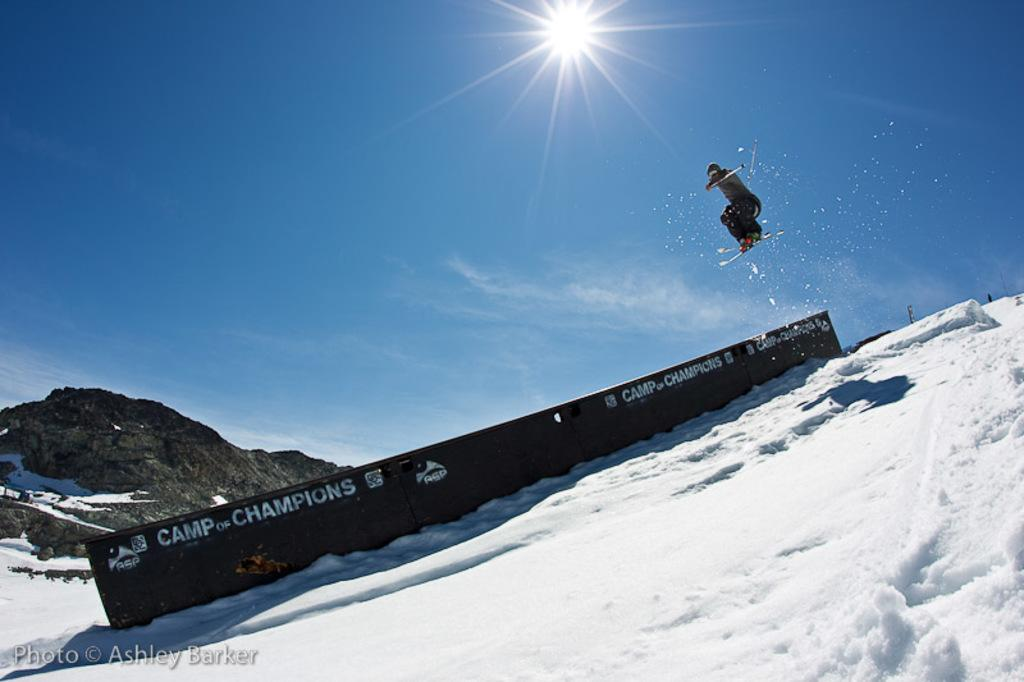<image>
Present a compact description of the photo's key features. a snow athlete is jumping over something that advertises Camp of champions 